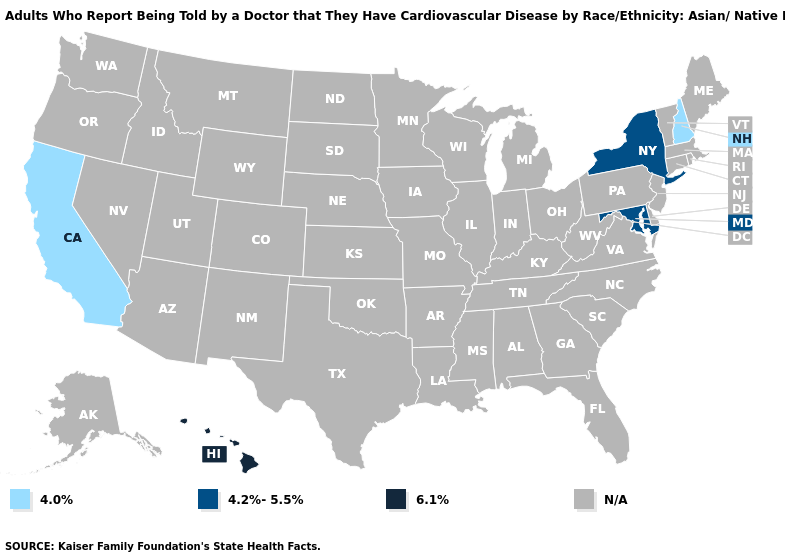What is the value of Oklahoma?
Be succinct. N/A. Name the states that have a value in the range N/A?
Write a very short answer. Alabama, Alaska, Arizona, Arkansas, Colorado, Connecticut, Delaware, Florida, Georgia, Idaho, Illinois, Indiana, Iowa, Kansas, Kentucky, Louisiana, Maine, Massachusetts, Michigan, Minnesota, Mississippi, Missouri, Montana, Nebraska, Nevada, New Jersey, New Mexico, North Carolina, North Dakota, Ohio, Oklahoma, Oregon, Pennsylvania, Rhode Island, South Carolina, South Dakota, Tennessee, Texas, Utah, Vermont, Virginia, Washington, West Virginia, Wisconsin, Wyoming. Name the states that have a value in the range 4.0%?
Give a very brief answer. California, New Hampshire. Name the states that have a value in the range N/A?
Short answer required. Alabama, Alaska, Arizona, Arkansas, Colorado, Connecticut, Delaware, Florida, Georgia, Idaho, Illinois, Indiana, Iowa, Kansas, Kentucky, Louisiana, Maine, Massachusetts, Michigan, Minnesota, Mississippi, Missouri, Montana, Nebraska, Nevada, New Jersey, New Mexico, North Carolina, North Dakota, Ohio, Oklahoma, Oregon, Pennsylvania, Rhode Island, South Carolina, South Dakota, Tennessee, Texas, Utah, Vermont, Virginia, Washington, West Virginia, Wisconsin, Wyoming. Name the states that have a value in the range 6.1%?
Short answer required. Hawaii. What is the value of Florida?
Write a very short answer. N/A. Name the states that have a value in the range 4.2%-5.5%?
Short answer required. Maryland, New York. How many symbols are there in the legend?
Short answer required. 4. What is the lowest value in the USA?
Concise answer only. 4.0%. What is the value of Iowa?
Short answer required. N/A. Name the states that have a value in the range 4.2%-5.5%?
Be succinct. Maryland, New York. Name the states that have a value in the range 4.2%-5.5%?
Give a very brief answer. Maryland, New York. What is the highest value in the USA?
Concise answer only. 6.1%. 